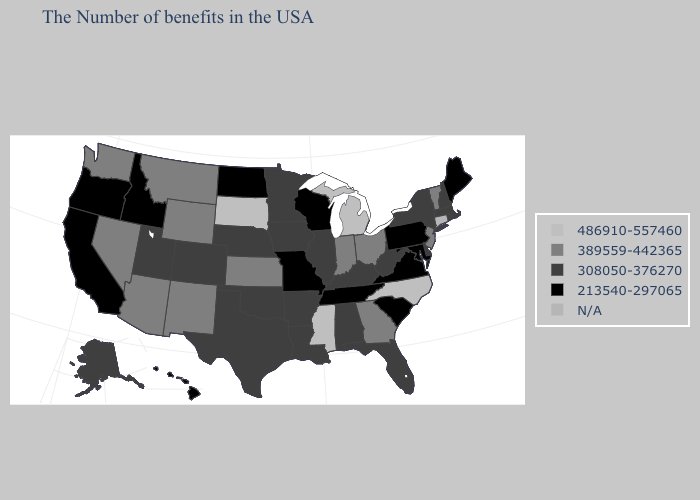Which states hav the highest value in the West?
Short answer required. Wyoming, New Mexico, Montana, Arizona, Nevada, Washington. Which states have the lowest value in the USA?
Give a very brief answer. Maine, Maryland, Pennsylvania, Virginia, South Carolina, Tennessee, Wisconsin, Missouri, North Dakota, Idaho, California, Oregon, Hawaii. What is the highest value in the Northeast ?
Give a very brief answer. 389559-442365. Among the states that border Delaware , does New Jersey have the lowest value?
Keep it brief. No. What is the value of Massachusetts?
Concise answer only. 308050-376270. Which states have the lowest value in the Northeast?
Quick response, please. Maine, Pennsylvania. Among the states that border Pennsylvania , does West Virginia have the lowest value?
Quick response, please. No. Among the states that border Kansas , does Missouri have the lowest value?
Answer briefly. Yes. Does the map have missing data?
Answer briefly. Yes. Which states have the lowest value in the West?
Answer briefly. Idaho, California, Oregon, Hawaii. Does the first symbol in the legend represent the smallest category?
Answer briefly. No. Name the states that have a value in the range 389559-442365?
Give a very brief answer. Vermont, New Jersey, Ohio, Georgia, Indiana, Kansas, Wyoming, New Mexico, Montana, Arizona, Nevada, Washington. Is the legend a continuous bar?
Short answer required. No. 